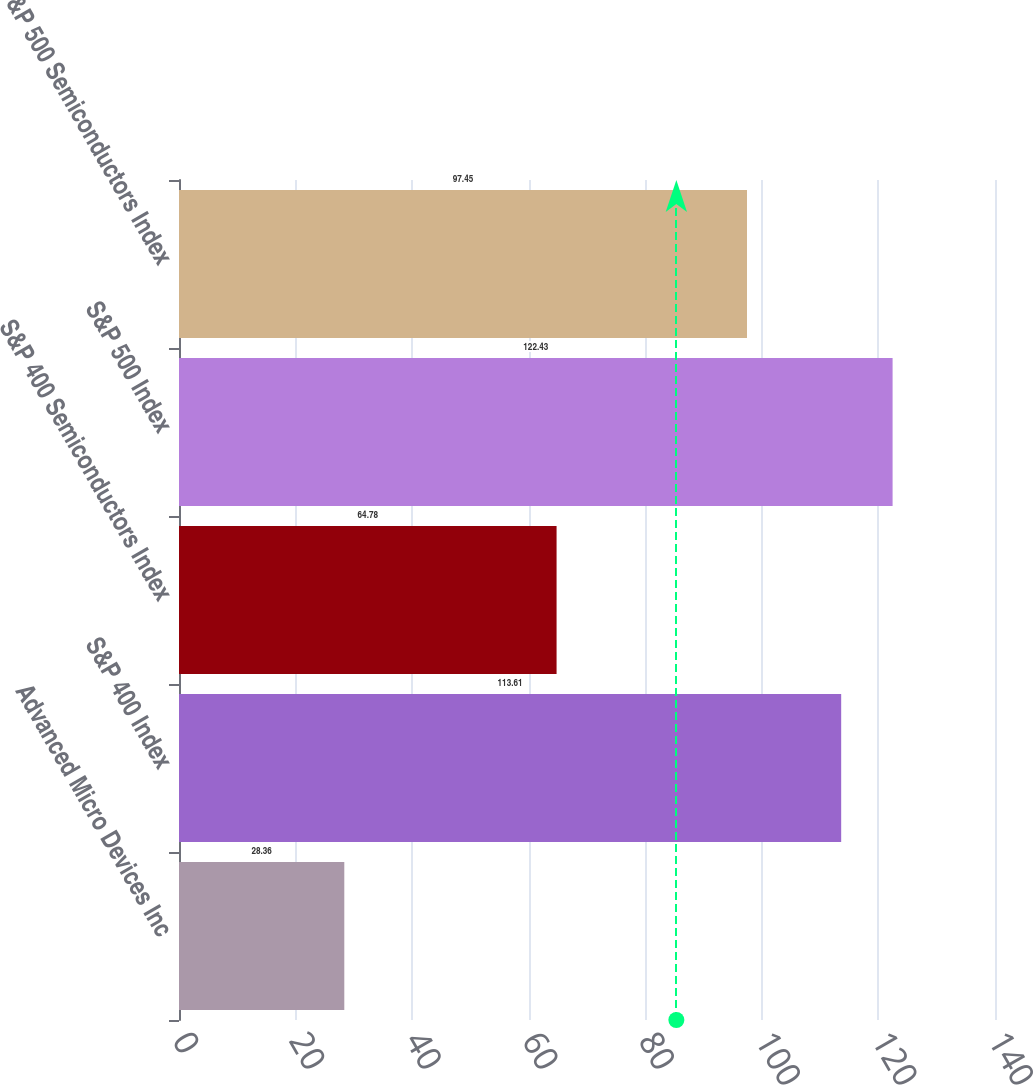Convert chart to OTSL. <chart><loc_0><loc_0><loc_500><loc_500><bar_chart><fcel>Advanced Micro Devices Inc<fcel>S&P 400 Index<fcel>S&P 400 Semiconductors Index<fcel>S&P 500 Index<fcel>S&P 500 Semiconductors Index<nl><fcel>28.36<fcel>113.61<fcel>64.78<fcel>122.43<fcel>97.45<nl></chart> 